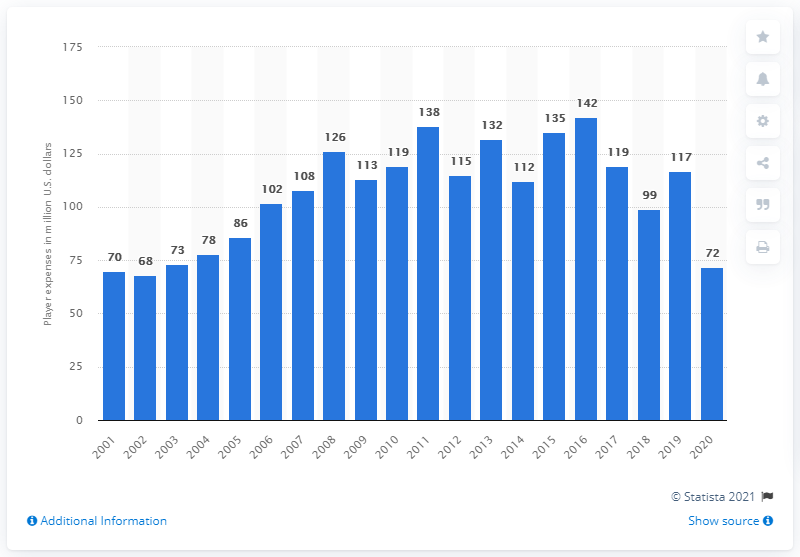Give some essential details in this illustration. The payroll of the Chicago White Sox in dollars was approximately 72 million in 2020. 